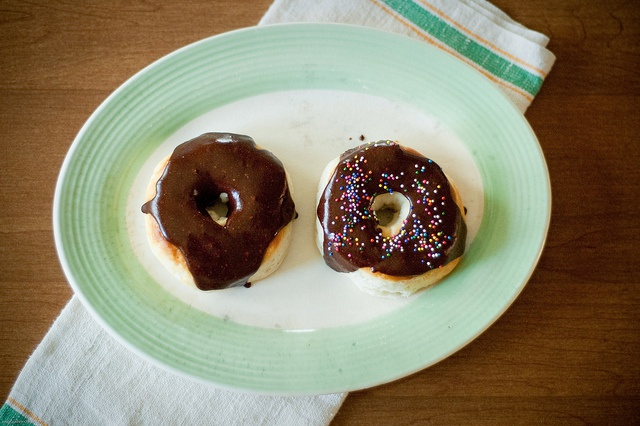Describe the objects in this image and their specific colors. I can see dining table in maroon, lightgray, beige, black, and lightblue tones, donut in maroon, black, beige, and tan tones, and donut in maroon, black, lightgray, and gray tones in this image. 